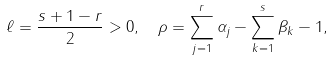Convert formula to latex. <formula><loc_0><loc_0><loc_500><loc_500>\ell & = \frac { s + 1 - r } { 2 } > 0 , \quad \rho = \sum _ { j = 1 } ^ { r } \alpha _ { j } - \sum _ { k = 1 } ^ { s } \beta _ { k } - 1 ,</formula> 